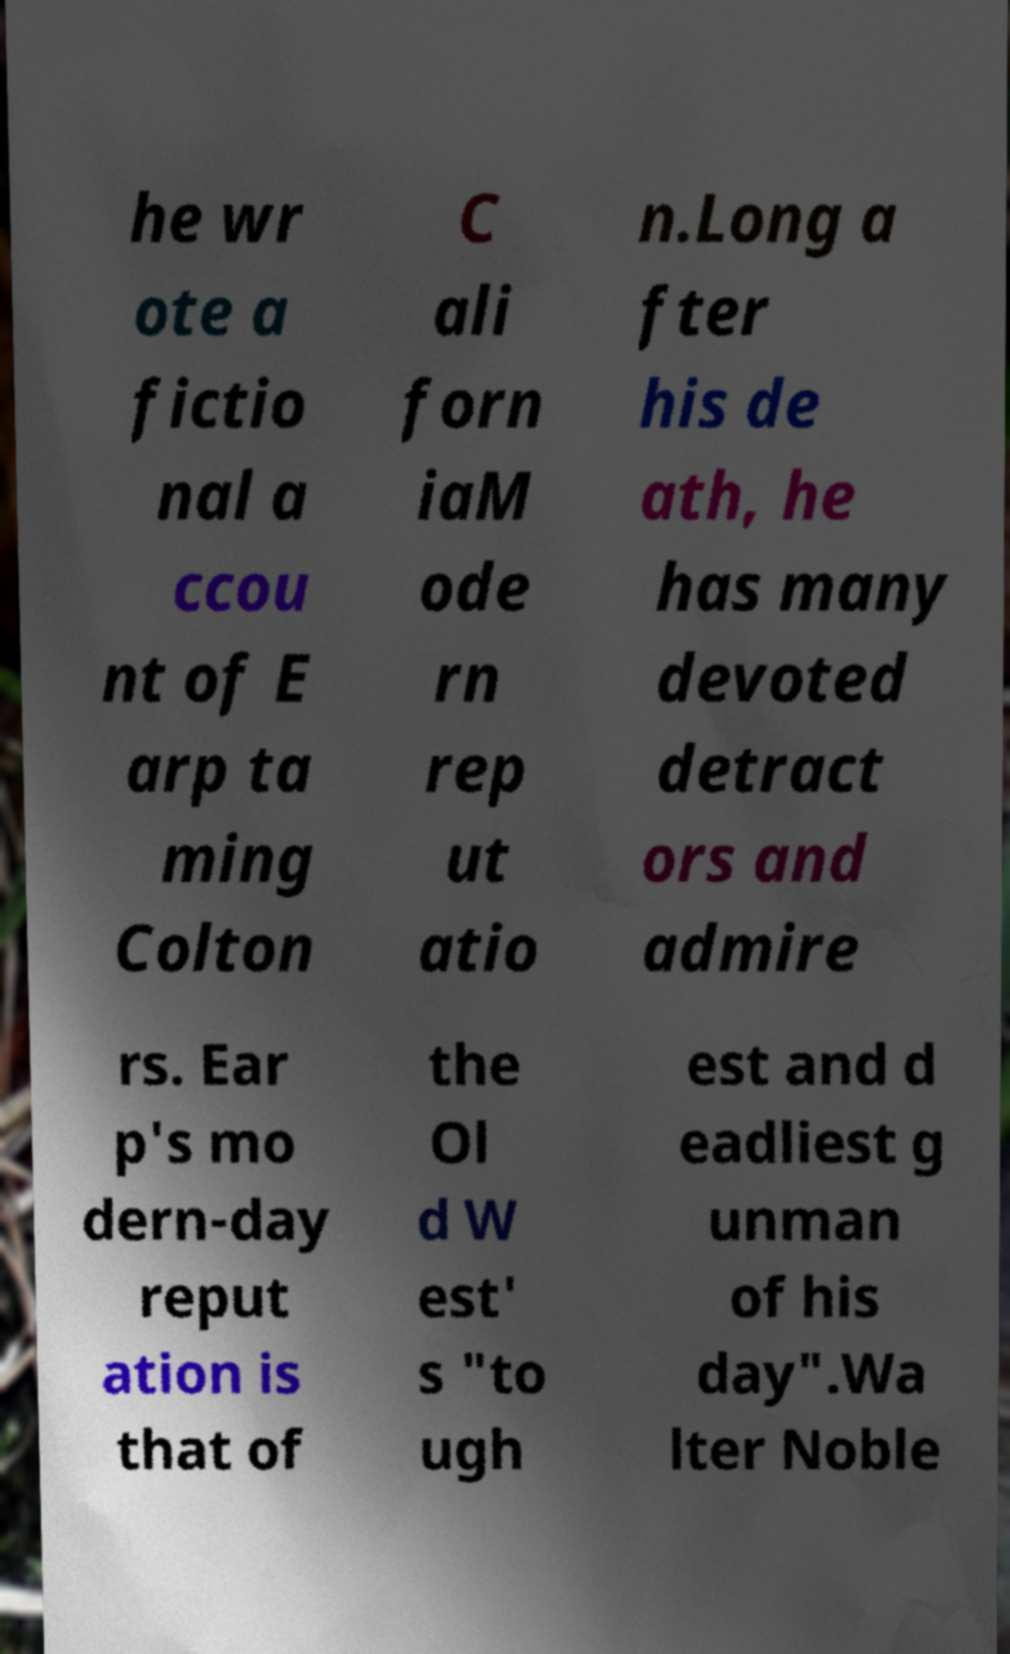Could you assist in decoding the text presented in this image and type it out clearly? he wr ote a fictio nal a ccou nt of E arp ta ming Colton C ali forn iaM ode rn rep ut atio n.Long a fter his de ath, he has many devoted detract ors and admire rs. Ear p's mo dern-day reput ation is that of the Ol d W est' s "to ugh est and d eadliest g unman of his day".Wa lter Noble 